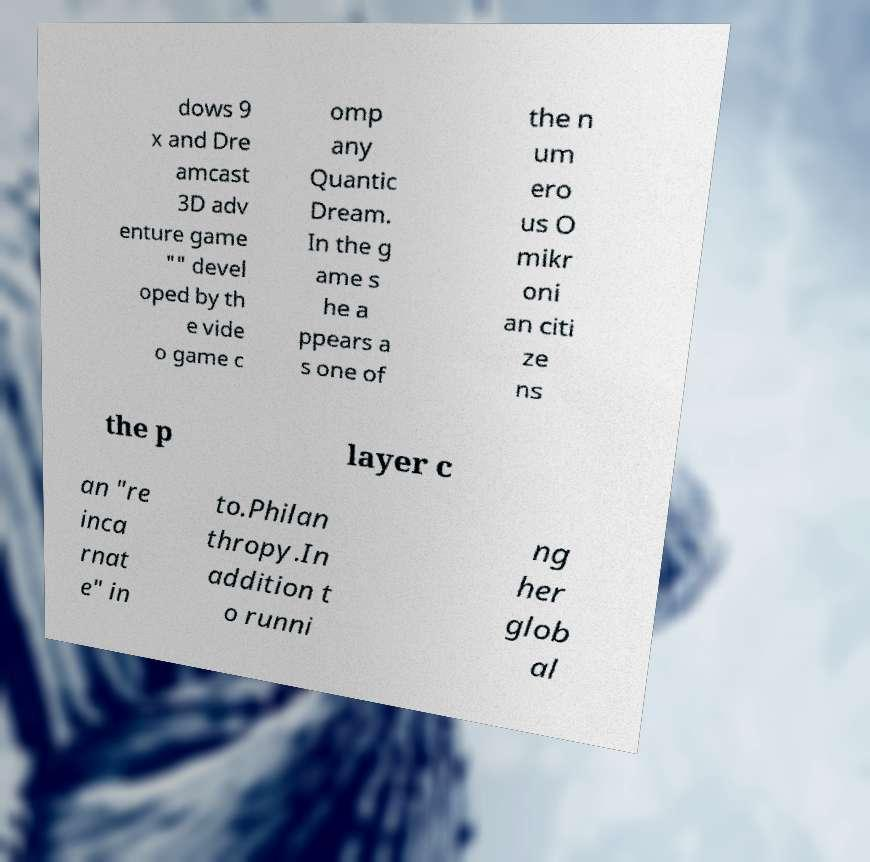Could you extract and type out the text from this image? dows 9 x and Dre amcast 3D adv enture game "" devel oped by th e vide o game c omp any Quantic Dream. In the g ame s he a ppears a s one of the n um ero us O mikr oni an citi ze ns the p layer c an "re inca rnat e" in to.Philan thropy.In addition t o runni ng her glob al 